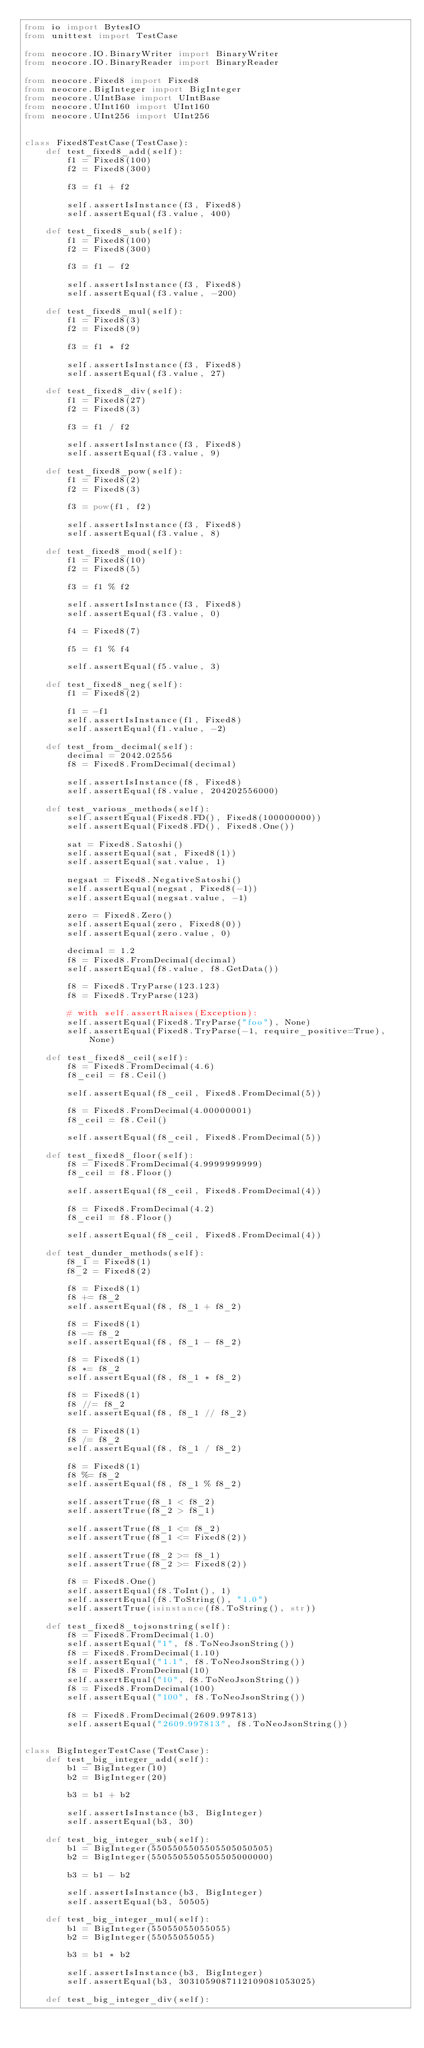<code> <loc_0><loc_0><loc_500><loc_500><_Python_>from io import BytesIO
from unittest import TestCase

from neocore.IO.BinaryWriter import BinaryWriter
from neocore.IO.BinaryReader import BinaryReader

from neocore.Fixed8 import Fixed8
from neocore.BigInteger import BigInteger
from neocore.UIntBase import UIntBase
from neocore.UInt160 import UInt160
from neocore.UInt256 import UInt256


class Fixed8TestCase(TestCase):
    def test_fixed8_add(self):
        f1 = Fixed8(100)
        f2 = Fixed8(300)

        f3 = f1 + f2

        self.assertIsInstance(f3, Fixed8)
        self.assertEqual(f3.value, 400)

    def test_fixed8_sub(self):
        f1 = Fixed8(100)
        f2 = Fixed8(300)

        f3 = f1 - f2

        self.assertIsInstance(f3, Fixed8)
        self.assertEqual(f3.value, -200)

    def test_fixed8_mul(self):
        f1 = Fixed8(3)
        f2 = Fixed8(9)

        f3 = f1 * f2

        self.assertIsInstance(f3, Fixed8)
        self.assertEqual(f3.value, 27)

    def test_fixed8_div(self):
        f1 = Fixed8(27)
        f2 = Fixed8(3)

        f3 = f1 / f2

        self.assertIsInstance(f3, Fixed8)
        self.assertEqual(f3.value, 9)

    def test_fixed8_pow(self):
        f1 = Fixed8(2)
        f2 = Fixed8(3)

        f3 = pow(f1, f2)

        self.assertIsInstance(f3, Fixed8)
        self.assertEqual(f3.value, 8)

    def test_fixed8_mod(self):
        f1 = Fixed8(10)
        f2 = Fixed8(5)

        f3 = f1 % f2

        self.assertIsInstance(f3, Fixed8)
        self.assertEqual(f3.value, 0)

        f4 = Fixed8(7)

        f5 = f1 % f4

        self.assertEqual(f5.value, 3)

    def test_fixed8_neg(self):
        f1 = Fixed8(2)

        f1 = -f1
        self.assertIsInstance(f1, Fixed8)
        self.assertEqual(f1.value, -2)

    def test_from_decimal(self):
        decimal = 2042.02556
        f8 = Fixed8.FromDecimal(decimal)

        self.assertIsInstance(f8, Fixed8)
        self.assertEqual(f8.value, 204202556000)

    def test_various_methods(self):
        self.assertEqual(Fixed8.FD(), Fixed8(100000000))
        self.assertEqual(Fixed8.FD(), Fixed8.One())

        sat = Fixed8.Satoshi()
        self.assertEqual(sat, Fixed8(1))
        self.assertEqual(sat.value, 1)

        negsat = Fixed8.NegativeSatoshi()
        self.assertEqual(negsat, Fixed8(-1))
        self.assertEqual(negsat.value, -1)

        zero = Fixed8.Zero()
        self.assertEqual(zero, Fixed8(0))
        self.assertEqual(zero.value, 0)

        decimal = 1.2
        f8 = Fixed8.FromDecimal(decimal)
        self.assertEqual(f8.value, f8.GetData())

        f8 = Fixed8.TryParse(123.123)
        f8 = Fixed8.TryParse(123)

        # with self.assertRaises(Exception):
        self.assertEqual(Fixed8.TryParse("foo"), None)
        self.assertEqual(Fixed8.TryParse(-1, require_positive=True), None)

    def test_fixed8_ceil(self):
        f8 = Fixed8.FromDecimal(4.6)
        f8_ceil = f8.Ceil()

        self.assertEqual(f8_ceil, Fixed8.FromDecimal(5))

        f8 = Fixed8.FromDecimal(4.00000001)
        f8_ceil = f8.Ceil()

        self.assertEqual(f8_ceil, Fixed8.FromDecimal(5))

    def test_fixed8_floor(self):
        f8 = Fixed8.FromDecimal(4.9999999999)
        f8_ceil = f8.Floor()

        self.assertEqual(f8_ceil, Fixed8.FromDecimal(4))

        f8 = Fixed8.FromDecimal(4.2)
        f8_ceil = f8.Floor()

        self.assertEqual(f8_ceil, Fixed8.FromDecimal(4))

    def test_dunder_methods(self):
        f8_1 = Fixed8(1)
        f8_2 = Fixed8(2)

        f8 = Fixed8(1)
        f8 += f8_2
        self.assertEqual(f8, f8_1 + f8_2)

        f8 = Fixed8(1)
        f8 -= f8_2
        self.assertEqual(f8, f8_1 - f8_2)

        f8 = Fixed8(1)
        f8 *= f8_2
        self.assertEqual(f8, f8_1 * f8_2)

        f8 = Fixed8(1)
        f8 //= f8_2
        self.assertEqual(f8, f8_1 // f8_2)

        f8 = Fixed8(1)
        f8 /= f8_2
        self.assertEqual(f8, f8_1 / f8_2)

        f8 = Fixed8(1)
        f8 %= f8_2
        self.assertEqual(f8, f8_1 % f8_2)

        self.assertTrue(f8_1 < f8_2)
        self.assertTrue(f8_2 > f8_1)

        self.assertTrue(f8_1 <= f8_2)
        self.assertTrue(f8_1 <= Fixed8(2))

        self.assertTrue(f8_2 >= f8_1)
        self.assertTrue(f8_2 >= Fixed8(2))

        f8 = Fixed8.One()
        self.assertEqual(f8.ToInt(), 1)
        self.assertEqual(f8.ToString(), "1.0")
        self.assertTrue(isinstance(f8.ToString(), str))

    def test_fixed8_tojsonstring(self):
        f8 = Fixed8.FromDecimal(1.0)
        self.assertEqual("1", f8.ToNeoJsonString())
        f8 = Fixed8.FromDecimal(1.10)
        self.assertEqual("1.1", f8.ToNeoJsonString())
        f8 = Fixed8.FromDecimal(10)
        self.assertEqual("10", f8.ToNeoJsonString())
        f8 = Fixed8.FromDecimal(100)
        self.assertEqual("100", f8.ToNeoJsonString())

        f8 = Fixed8.FromDecimal(2609.997813)
        self.assertEqual("2609.997813", f8.ToNeoJsonString())


class BigIntegerTestCase(TestCase):
    def test_big_integer_add(self):
        b1 = BigInteger(10)
        b2 = BigInteger(20)

        b3 = b1 + b2

        self.assertIsInstance(b3, BigInteger)
        self.assertEqual(b3, 30)

    def test_big_integer_sub(self):
        b1 = BigInteger(5505505505505505050505)
        b2 = BigInteger(5505505505505505000000)

        b3 = b1 - b2

        self.assertIsInstance(b3, BigInteger)
        self.assertEqual(b3, 50505)

    def test_big_integer_mul(self):
        b1 = BigInteger(55055055055055)
        b2 = BigInteger(55055055055)

        b3 = b1 * b2

        self.assertIsInstance(b3, BigInteger)
        self.assertEqual(b3, 3031059087112109081053025)

    def test_big_integer_div(self):</code> 